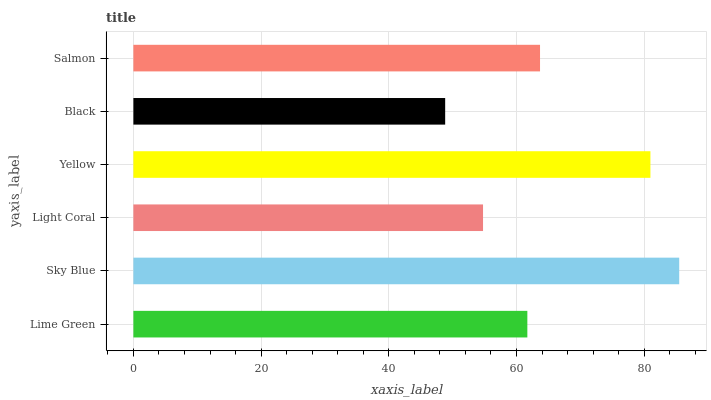Is Black the minimum?
Answer yes or no. Yes. Is Sky Blue the maximum?
Answer yes or no. Yes. Is Light Coral the minimum?
Answer yes or no. No. Is Light Coral the maximum?
Answer yes or no. No. Is Sky Blue greater than Light Coral?
Answer yes or no. Yes. Is Light Coral less than Sky Blue?
Answer yes or no. Yes. Is Light Coral greater than Sky Blue?
Answer yes or no. No. Is Sky Blue less than Light Coral?
Answer yes or no. No. Is Salmon the high median?
Answer yes or no. Yes. Is Lime Green the low median?
Answer yes or no. Yes. Is Sky Blue the high median?
Answer yes or no. No. Is Salmon the low median?
Answer yes or no. No. 